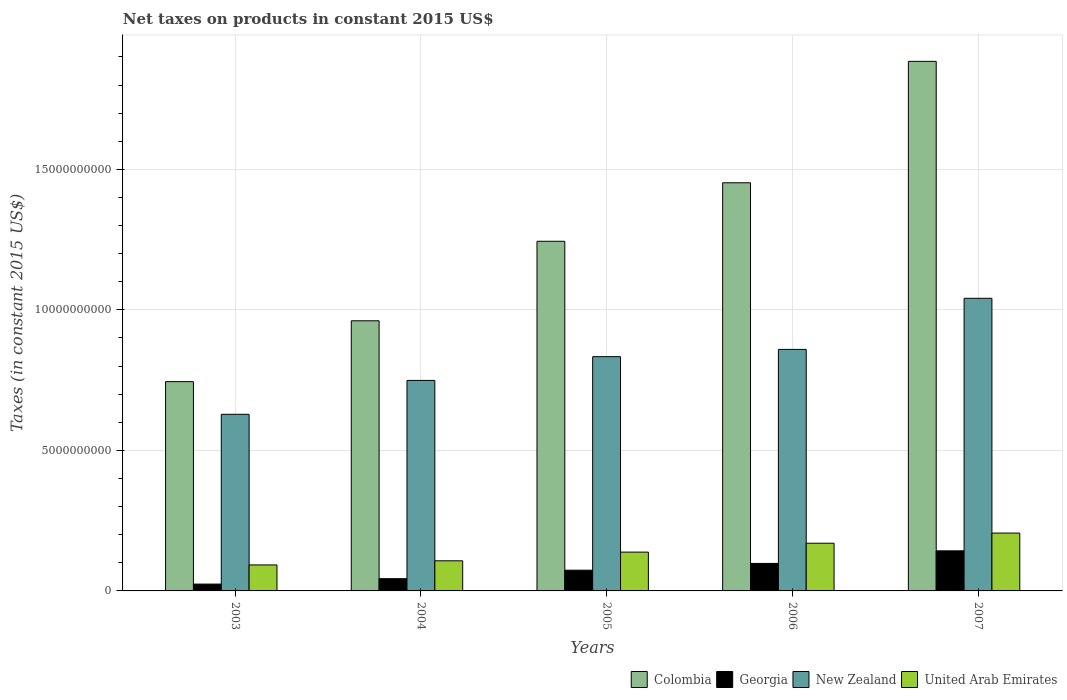How many different coloured bars are there?
Make the answer very short. 4. How many groups of bars are there?
Keep it short and to the point. 5. Are the number of bars on each tick of the X-axis equal?
Ensure brevity in your answer.  Yes. How many bars are there on the 4th tick from the right?
Your response must be concise. 4. What is the net taxes on products in Colombia in 2005?
Make the answer very short. 1.24e+1. Across all years, what is the maximum net taxes on products in New Zealand?
Make the answer very short. 1.04e+1. Across all years, what is the minimum net taxes on products in United Arab Emirates?
Offer a terse response. 9.25e+08. What is the total net taxes on products in New Zealand in the graph?
Keep it short and to the point. 4.11e+1. What is the difference between the net taxes on products in Georgia in 2005 and that in 2007?
Provide a succinct answer. -6.89e+08. What is the difference between the net taxes on products in Georgia in 2005 and the net taxes on products in Colombia in 2006?
Ensure brevity in your answer.  -1.38e+1. What is the average net taxes on products in Colombia per year?
Offer a terse response. 1.26e+1. In the year 2007, what is the difference between the net taxes on products in Colombia and net taxes on products in New Zealand?
Ensure brevity in your answer.  8.43e+09. What is the ratio of the net taxes on products in United Arab Emirates in 2003 to that in 2005?
Provide a succinct answer. 0.67. What is the difference between the highest and the second highest net taxes on products in Georgia?
Provide a short and direct response. 4.47e+08. What is the difference between the highest and the lowest net taxes on products in Colombia?
Make the answer very short. 1.14e+1. Is the sum of the net taxes on products in Georgia in 2004 and 2007 greater than the maximum net taxes on products in Colombia across all years?
Provide a short and direct response. No. Is it the case that in every year, the sum of the net taxes on products in New Zealand and net taxes on products in Georgia is greater than the sum of net taxes on products in Colombia and net taxes on products in United Arab Emirates?
Give a very brief answer. No. What does the 3rd bar from the left in 2006 represents?
Make the answer very short. New Zealand. What does the 1st bar from the right in 2005 represents?
Your answer should be compact. United Arab Emirates. How many years are there in the graph?
Your answer should be compact. 5. Are the values on the major ticks of Y-axis written in scientific E-notation?
Your answer should be very brief. No. Does the graph contain any zero values?
Your answer should be compact. No. How many legend labels are there?
Provide a short and direct response. 4. What is the title of the graph?
Your answer should be very brief. Net taxes on products in constant 2015 US$. Does "Kiribati" appear as one of the legend labels in the graph?
Offer a very short reply. No. What is the label or title of the Y-axis?
Keep it short and to the point. Taxes (in constant 2015 US$). What is the Taxes (in constant 2015 US$) of Colombia in 2003?
Give a very brief answer. 7.45e+09. What is the Taxes (in constant 2015 US$) in Georgia in 2003?
Your response must be concise. 2.43e+08. What is the Taxes (in constant 2015 US$) of New Zealand in 2003?
Make the answer very short. 6.28e+09. What is the Taxes (in constant 2015 US$) of United Arab Emirates in 2003?
Your answer should be compact. 9.25e+08. What is the Taxes (in constant 2015 US$) in Colombia in 2004?
Offer a terse response. 9.61e+09. What is the Taxes (in constant 2015 US$) in Georgia in 2004?
Your answer should be very brief. 4.35e+08. What is the Taxes (in constant 2015 US$) in New Zealand in 2004?
Offer a very short reply. 7.49e+09. What is the Taxes (in constant 2015 US$) in United Arab Emirates in 2004?
Make the answer very short. 1.07e+09. What is the Taxes (in constant 2015 US$) of Colombia in 2005?
Offer a very short reply. 1.24e+1. What is the Taxes (in constant 2015 US$) of Georgia in 2005?
Make the answer very short. 7.37e+08. What is the Taxes (in constant 2015 US$) of New Zealand in 2005?
Give a very brief answer. 8.34e+09. What is the Taxes (in constant 2015 US$) in United Arab Emirates in 2005?
Offer a very short reply. 1.38e+09. What is the Taxes (in constant 2015 US$) in Colombia in 2006?
Give a very brief answer. 1.45e+1. What is the Taxes (in constant 2015 US$) in Georgia in 2006?
Provide a short and direct response. 9.79e+08. What is the Taxes (in constant 2015 US$) in New Zealand in 2006?
Give a very brief answer. 8.59e+09. What is the Taxes (in constant 2015 US$) of United Arab Emirates in 2006?
Provide a short and direct response. 1.70e+09. What is the Taxes (in constant 2015 US$) in Colombia in 2007?
Your answer should be very brief. 1.88e+1. What is the Taxes (in constant 2015 US$) of Georgia in 2007?
Give a very brief answer. 1.43e+09. What is the Taxes (in constant 2015 US$) of New Zealand in 2007?
Make the answer very short. 1.04e+1. What is the Taxes (in constant 2015 US$) in United Arab Emirates in 2007?
Provide a short and direct response. 2.06e+09. Across all years, what is the maximum Taxes (in constant 2015 US$) of Colombia?
Offer a very short reply. 1.88e+1. Across all years, what is the maximum Taxes (in constant 2015 US$) of Georgia?
Keep it short and to the point. 1.43e+09. Across all years, what is the maximum Taxes (in constant 2015 US$) in New Zealand?
Keep it short and to the point. 1.04e+1. Across all years, what is the maximum Taxes (in constant 2015 US$) of United Arab Emirates?
Give a very brief answer. 2.06e+09. Across all years, what is the minimum Taxes (in constant 2015 US$) in Colombia?
Your answer should be very brief. 7.45e+09. Across all years, what is the minimum Taxes (in constant 2015 US$) of Georgia?
Offer a very short reply. 2.43e+08. Across all years, what is the minimum Taxes (in constant 2015 US$) of New Zealand?
Your answer should be compact. 6.28e+09. Across all years, what is the minimum Taxes (in constant 2015 US$) in United Arab Emirates?
Ensure brevity in your answer.  9.25e+08. What is the total Taxes (in constant 2015 US$) of Colombia in the graph?
Provide a short and direct response. 6.29e+1. What is the total Taxes (in constant 2015 US$) of Georgia in the graph?
Your answer should be very brief. 3.82e+09. What is the total Taxes (in constant 2015 US$) of New Zealand in the graph?
Your answer should be very brief. 4.11e+1. What is the total Taxes (in constant 2015 US$) in United Arab Emirates in the graph?
Offer a very short reply. 7.13e+09. What is the difference between the Taxes (in constant 2015 US$) in Colombia in 2003 and that in 2004?
Provide a succinct answer. -2.17e+09. What is the difference between the Taxes (in constant 2015 US$) of Georgia in 2003 and that in 2004?
Offer a terse response. -1.92e+08. What is the difference between the Taxes (in constant 2015 US$) in New Zealand in 2003 and that in 2004?
Provide a succinct answer. -1.21e+09. What is the difference between the Taxes (in constant 2015 US$) of United Arab Emirates in 2003 and that in 2004?
Provide a succinct answer. -1.47e+08. What is the difference between the Taxes (in constant 2015 US$) of Colombia in 2003 and that in 2005?
Make the answer very short. -5.00e+09. What is the difference between the Taxes (in constant 2015 US$) of Georgia in 2003 and that in 2005?
Keep it short and to the point. -4.94e+08. What is the difference between the Taxes (in constant 2015 US$) in New Zealand in 2003 and that in 2005?
Give a very brief answer. -2.05e+09. What is the difference between the Taxes (in constant 2015 US$) in United Arab Emirates in 2003 and that in 2005?
Provide a short and direct response. -4.56e+08. What is the difference between the Taxes (in constant 2015 US$) of Colombia in 2003 and that in 2006?
Provide a short and direct response. -7.08e+09. What is the difference between the Taxes (in constant 2015 US$) of Georgia in 2003 and that in 2006?
Ensure brevity in your answer.  -7.36e+08. What is the difference between the Taxes (in constant 2015 US$) of New Zealand in 2003 and that in 2006?
Provide a succinct answer. -2.31e+09. What is the difference between the Taxes (in constant 2015 US$) of United Arab Emirates in 2003 and that in 2006?
Provide a short and direct response. -7.73e+08. What is the difference between the Taxes (in constant 2015 US$) of Colombia in 2003 and that in 2007?
Offer a terse response. -1.14e+1. What is the difference between the Taxes (in constant 2015 US$) of Georgia in 2003 and that in 2007?
Your answer should be very brief. -1.18e+09. What is the difference between the Taxes (in constant 2015 US$) of New Zealand in 2003 and that in 2007?
Your answer should be compact. -4.13e+09. What is the difference between the Taxes (in constant 2015 US$) of United Arab Emirates in 2003 and that in 2007?
Offer a terse response. -1.13e+09. What is the difference between the Taxes (in constant 2015 US$) of Colombia in 2004 and that in 2005?
Provide a succinct answer. -2.83e+09. What is the difference between the Taxes (in constant 2015 US$) of Georgia in 2004 and that in 2005?
Your answer should be very brief. -3.02e+08. What is the difference between the Taxes (in constant 2015 US$) of New Zealand in 2004 and that in 2005?
Your answer should be compact. -8.45e+08. What is the difference between the Taxes (in constant 2015 US$) of United Arab Emirates in 2004 and that in 2005?
Your response must be concise. -3.09e+08. What is the difference between the Taxes (in constant 2015 US$) of Colombia in 2004 and that in 2006?
Offer a very short reply. -4.91e+09. What is the difference between the Taxes (in constant 2015 US$) in Georgia in 2004 and that in 2006?
Your answer should be compact. -5.44e+08. What is the difference between the Taxes (in constant 2015 US$) of New Zealand in 2004 and that in 2006?
Provide a succinct answer. -1.10e+09. What is the difference between the Taxes (in constant 2015 US$) of United Arab Emirates in 2004 and that in 2006?
Ensure brevity in your answer.  -6.26e+08. What is the difference between the Taxes (in constant 2015 US$) in Colombia in 2004 and that in 2007?
Keep it short and to the point. -9.23e+09. What is the difference between the Taxes (in constant 2015 US$) of Georgia in 2004 and that in 2007?
Provide a succinct answer. -9.91e+08. What is the difference between the Taxes (in constant 2015 US$) in New Zealand in 2004 and that in 2007?
Offer a terse response. -2.92e+09. What is the difference between the Taxes (in constant 2015 US$) of United Arab Emirates in 2004 and that in 2007?
Your answer should be compact. -9.87e+08. What is the difference between the Taxes (in constant 2015 US$) of Colombia in 2005 and that in 2006?
Your response must be concise. -2.08e+09. What is the difference between the Taxes (in constant 2015 US$) in Georgia in 2005 and that in 2006?
Your answer should be very brief. -2.42e+08. What is the difference between the Taxes (in constant 2015 US$) in New Zealand in 2005 and that in 2006?
Make the answer very short. -2.59e+08. What is the difference between the Taxes (in constant 2015 US$) in United Arab Emirates in 2005 and that in 2006?
Ensure brevity in your answer.  -3.17e+08. What is the difference between the Taxes (in constant 2015 US$) in Colombia in 2005 and that in 2007?
Provide a short and direct response. -6.40e+09. What is the difference between the Taxes (in constant 2015 US$) in Georgia in 2005 and that in 2007?
Your response must be concise. -6.89e+08. What is the difference between the Taxes (in constant 2015 US$) of New Zealand in 2005 and that in 2007?
Provide a short and direct response. -2.08e+09. What is the difference between the Taxes (in constant 2015 US$) in United Arab Emirates in 2005 and that in 2007?
Your response must be concise. -6.78e+08. What is the difference between the Taxes (in constant 2015 US$) in Colombia in 2006 and that in 2007?
Make the answer very short. -4.32e+09. What is the difference between the Taxes (in constant 2015 US$) of Georgia in 2006 and that in 2007?
Give a very brief answer. -4.47e+08. What is the difference between the Taxes (in constant 2015 US$) in New Zealand in 2006 and that in 2007?
Your answer should be compact. -1.82e+09. What is the difference between the Taxes (in constant 2015 US$) in United Arab Emirates in 2006 and that in 2007?
Your response must be concise. -3.61e+08. What is the difference between the Taxes (in constant 2015 US$) in Colombia in 2003 and the Taxes (in constant 2015 US$) in Georgia in 2004?
Offer a very short reply. 7.01e+09. What is the difference between the Taxes (in constant 2015 US$) of Colombia in 2003 and the Taxes (in constant 2015 US$) of New Zealand in 2004?
Provide a succinct answer. -4.41e+07. What is the difference between the Taxes (in constant 2015 US$) of Colombia in 2003 and the Taxes (in constant 2015 US$) of United Arab Emirates in 2004?
Offer a terse response. 6.38e+09. What is the difference between the Taxes (in constant 2015 US$) in Georgia in 2003 and the Taxes (in constant 2015 US$) in New Zealand in 2004?
Your answer should be compact. -7.25e+09. What is the difference between the Taxes (in constant 2015 US$) of Georgia in 2003 and the Taxes (in constant 2015 US$) of United Arab Emirates in 2004?
Provide a succinct answer. -8.28e+08. What is the difference between the Taxes (in constant 2015 US$) in New Zealand in 2003 and the Taxes (in constant 2015 US$) in United Arab Emirates in 2004?
Ensure brevity in your answer.  5.21e+09. What is the difference between the Taxes (in constant 2015 US$) in Colombia in 2003 and the Taxes (in constant 2015 US$) in Georgia in 2005?
Your answer should be very brief. 6.71e+09. What is the difference between the Taxes (in constant 2015 US$) in Colombia in 2003 and the Taxes (in constant 2015 US$) in New Zealand in 2005?
Offer a terse response. -8.89e+08. What is the difference between the Taxes (in constant 2015 US$) of Colombia in 2003 and the Taxes (in constant 2015 US$) of United Arab Emirates in 2005?
Offer a very short reply. 6.07e+09. What is the difference between the Taxes (in constant 2015 US$) of Georgia in 2003 and the Taxes (in constant 2015 US$) of New Zealand in 2005?
Ensure brevity in your answer.  -8.09e+09. What is the difference between the Taxes (in constant 2015 US$) of Georgia in 2003 and the Taxes (in constant 2015 US$) of United Arab Emirates in 2005?
Provide a short and direct response. -1.14e+09. What is the difference between the Taxes (in constant 2015 US$) in New Zealand in 2003 and the Taxes (in constant 2015 US$) in United Arab Emirates in 2005?
Provide a succinct answer. 4.90e+09. What is the difference between the Taxes (in constant 2015 US$) in Colombia in 2003 and the Taxes (in constant 2015 US$) in Georgia in 2006?
Provide a short and direct response. 6.47e+09. What is the difference between the Taxes (in constant 2015 US$) of Colombia in 2003 and the Taxes (in constant 2015 US$) of New Zealand in 2006?
Your response must be concise. -1.15e+09. What is the difference between the Taxes (in constant 2015 US$) in Colombia in 2003 and the Taxes (in constant 2015 US$) in United Arab Emirates in 2006?
Provide a short and direct response. 5.75e+09. What is the difference between the Taxes (in constant 2015 US$) in Georgia in 2003 and the Taxes (in constant 2015 US$) in New Zealand in 2006?
Offer a terse response. -8.35e+09. What is the difference between the Taxes (in constant 2015 US$) of Georgia in 2003 and the Taxes (in constant 2015 US$) of United Arab Emirates in 2006?
Offer a very short reply. -1.45e+09. What is the difference between the Taxes (in constant 2015 US$) of New Zealand in 2003 and the Taxes (in constant 2015 US$) of United Arab Emirates in 2006?
Your answer should be very brief. 4.59e+09. What is the difference between the Taxes (in constant 2015 US$) of Colombia in 2003 and the Taxes (in constant 2015 US$) of Georgia in 2007?
Provide a succinct answer. 6.02e+09. What is the difference between the Taxes (in constant 2015 US$) of Colombia in 2003 and the Taxes (in constant 2015 US$) of New Zealand in 2007?
Your answer should be very brief. -2.97e+09. What is the difference between the Taxes (in constant 2015 US$) in Colombia in 2003 and the Taxes (in constant 2015 US$) in United Arab Emirates in 2007?
Your answer should be compact. 5.39e+09. What is the difference between the Taxes (in constant 2015 US$) in Georgia in 2003 and the Taxes (in constant 2015 US$) in New Zealand in 2007?
Make the answer very short. -1.02e+1. What is the difference between the Taxes (in constant 2015 US$) of Georgia in 2003 and the Taxes (in constant 2015 US$) of United Arab Emirates in 2007?
Give a very brief answer. -1.81e+09. What is the difference between the Taxes (in constant 2015 US$) of New Zealand in 2003 and the Taxes (in constant 2015 US$) of United Arab Emirates in 2007?
Your answer should be compact. 4.23e+09. What is the difference between the Taxes (in constant 2015 US$) in Colombia in 2004 and the Taxes (in constant 2015 US$) in Georgia in 2005?
Offer a very short reply. 8.88e+09. What is the difference between the Taxes (in constant 2015 US$) of Colombia in 2004 and the Taxes (in constant 2015 US$) of New Zealand in 2005?
Make the answer very short. 1.28e+09. What is the difference between the Taxes (in constant 2015 US$) of Colombia in 2004 and the Taxes (in constant 2015 US$) of United Arab Emirates in 2005?
Provide a short and direct response. 8.23e+09. What is the difference between the Taxes (in constant 2015 US$) of Georgia in 2004 and the Taxes (in constant 2015 US$) of New Zealand in 2005?
Make the answer very short. -7.90e+09. What is the difference between the Taxes (in constant 2015 US$) of Georgia in 2004 and the Taxes (in constant 2015 US$) of United Arab Emirates in 2005?
Offer a terse response. -9.45e+08. What is the difference between the Taxes (in constant 2015 US$) of New Zealand in 2004 and the Taxes (in constant 2015 US$) of United Arab Emirates in 2005?
Keep it short and to the point. 6.11e+09. What is the difference between the Taxes (in constant 2015 US$) of Colombia in 2004 and the Taxes (in constant 2015 US$) of Georgia in 2006?
Ensure brevity in your answer.  8.63e+09. What is the difference between the Taxes (in constant 2015 US$) of Colombia in 2004 and the Taxes (in constant 2015 US$) of New Zealand in 2006?
Your answer should be compact. 1.02e+09. What is the difference between the Taxes (in constant 2015 US$) in Colombia in 2004 and the Taxes (in constant 2015 US$) in United Arab Emirates in 2006?
Ensure brevity in your answer.  7.92e+09. What is the difference between the Taxes (in constant 2015 US$) of Georgia in 2004 and the Taxes (in constant 2015 US$) of New Zealand in 2006?
Make the answer very short. -8.16e+09. What is the difference between the Taxes (in constant 2015 US$) of Georgia in 2004 and the Taxes (in constant 2015 US$) of United Arab Emirates in 2006?
Provide a short and direct response. -1.26e+09. What is the difference between the Taxes (in constant 2015 US$) of New Zealand in 2004 and the Taxes (in constant 2015 US$) of United Arab Emirates in 2006?
Offer a terse response. 5.79e+09. What is the difference between the Taxes (in constant 2015 US$) in Colombia in 2004 and the Taxes (in constant 2015 US$) in Georgia in 2007?
Offer a very short reply. 8.19e+09. What is the difference between the Taxes (in constant 2015 US$) of Colombia in 2004 and the Taxes (in constant 2015 US$) of New Zealand in 2007?
Give a very brief answer. -8.01e+08. What is the difference between the Taxes (in constant 2015 US$) in Colombia in 2004 and the Taxes (in constant 2015 US$) in United Arab Emirates in 2007?
Provide a succinct answer. 7.55e+09. What is the difference between the Taxes (in constant 2015 US$) of Georgia in 2004 and the Taxes (in constant 2015 US$) of New Zealand in 2007?
Provide a succinct answer. -9.98e+09. What is the difference between the Taxes (in constant 2015 US$) of Georgia in 2004 and the Taxes (in constant 2015 US$) of United Arab Emirates in 2007?
Ensure brevity in your answer.  -1.62e+09. What is the difference between the Taxes (in constant 2015 US$) in New Zealand in 2004 and the Taxes (in constant 2015 US$) in United Arab Emirates in 2007?
Keep it short and to the point. 5.43e+09. What is the difference between the Taxes (in constant 2015 US$) of Colombia in 2005 and the Taxes (in constant 2015 US$) of Georgia in 2006?
Offer a terse response. 1.15e+1. What is the difference between the Taxes (in constant 2015 US$) of Colombia in 2005 and the Taxes (in constant 2015 US$) of New Zealand in 2006?
Offer a terse response. 3.85e+09. What is the difference between the Taxes (in constant 2015 US$) in Colombia in 2005 and the Taxes (in constant 2015 US$) in United Arab Emirates in 2006?
Provide a short and direct response. 1.07e+1. What is the difference between the Taxes (in constant 2015 US$) of Georgia in 2005 and the Taxes (in constant 2015 US$) of New Zealand in 2006?
Give a very brief answer. -7.86e+09. What is the difference between the Taxes (in constant 2015 US$) in Georgia in 2005 and the Taxes (in constant 2015 US$) in United Arab Emirates in 2006?
Keep it short and to the point. -9.60e+08. What is the difference between the Taxes (in constant 2015 US$) of New Zealand in 2005 and the Taxes (in constant 2015 US$) of United Arab Emirates in 2006?
Your answer should be compact. 6.64e+09. What is the difference between the Taxes (in constant 2015 US$) in Colombia in 2005 and the Taxes (in constant 2015 US$) in Georgia in 2007?
Provide a short and direct response. 1.10e+1. What is the difference between the Taxes (in constant 2015 US$) of Colombia in 2005 and the Taxes (in constant 2015 US$) of New Zealand in 2007?
Offer a very short reply. 2.03e+09. What is the difference between the Taxes (in constant 2015 US$) in Colombia in 2005 and the Taxes (in constant 2015 US$) in United Arab Emirates in 2007?
Provide a short and direct response. 1.04e+1. What is the difference between the Taxes (in constant 2015 US$) of Georgia in 2005 and the Taxes (in constant 2015 US$) of New Zealand in 2007?
Provide a short and direct response. -9.68e+09. What is the difference between the Taxes (in constant 2015 US$) of Georgia in 2005 and the Taxes (in constant 2015 US$) of United Arab Emirates in 2007?
Ensure brevity in your answer.  -1.32e+09. What is the difference between the Taxes (in constant 2015 US$) in New Zealand in 2005 and the Taxes (in constant 2015 US$) in United Arab Emirates in 2007?
Provide a succinct answer. 6.28e+09. What is the difference between the Taxes (in constant 2015 US$) in Colombia in 2006 and the Taxes (in constant 2015 US$) in Georgia in 2007?
Your response must be concise. 1.31e+1. What is the difference between the Taxes (in constant 2015 US$) in Colombia in 2006 and the Taxes (in constant 2015 US$) in New Zealand in 2007?
Offer a terse response. 4.11e+09. What is the difference between the Taxes (in constant 2015 US$) in Colombia in 2006 and the Taxes (in constant 2015 US$) in United Arab Emirates in 2007?
Offer a terse response. 1.25e+1. What is the difference between the Taxes (in constant 2015 US$) in Georgia in 2006 and the Taxes (in constant 2015 US$) in New Zealand in 2007?
Offer a terse response. -9.43e+09. What is the difference between the Taxes (in constant 2015 US$) of Georgia in 2006 and the Taxes (in constant 2015 US$) of United Arab Emirates in 2007?
Offer a very short reply. -1.08e+09. What is the difference between the Taxes (in constant 2015 US$) of New Zealand in 2006 and the Taxes (in constant 2015 US$) of United Arab Emirates in 2007?
Provide a short and direct response. 6.54e+09. What is the average Taxes (in constant 2015 US$) of Colombia per year?
Ensure brevity in your answer.  1.26e+1. What is the average Taxes (in constant 2015 US$) of Georgia per year?
Make the answer very short. 7.64e+08. What is the average Taxes (in constant 2015 US$) in New Zealand per year?
Offer a very short reply. 8.22e+09. What is the average Taxes (in constant 2015 US$) of United Arab Emirates per year?
Give a very brief answer. 1.43e+09. In the year 2003, what is the difference between the Taxes (in constant 2015 US$) of Colombia and Taxes (in constant 2015 US$) of Georgia?
Provide a succinct answer. 7.20e+09. In the year 2003, what is the difference between the Taxes (in constant 2015 US$) of Colombia and Taxes (in constant 2015 US$) of New Zealand?
Give a very brief answer. 1.16e+09. In the year 2003, what is the difference between the Taxes (in constant 2015 US$) of Colombia and Taxes (in constant 2015 US$) of United Arab Emirates?
Offer a very short reply. 6.52e+09. In the year 2003, what is the difference between the Taxes (in constant 2015 US$) in Georgia and Taxes (in constant 2015 US$) in New Zealand?
Provide a succinct answer. -6.04e+09. In the year 2003, what is the difference between the Taxes (in constant 2015 US$) of Georgia and Taxes (in constant 2015 US$) of United Arab Emirates?
Your answer should be compact. -6.81e+08. In the year 2003, what is the difference between the Taxes (in constant 2015 US$) in New Zealand and Taxes (in constant 2015 US$) in United Arab Emirates?
Give a very brief answer. 5.36e+09. In the year 2004, what is the difference between the Taxes (in constant 2015 US$) of Colombia and Taxes (in constant 2015 US$) of Georgia?
Provide a succinct answer. 9.18e+09. In the year 2004, what is the difference between the Taxes (in constant 2015 US$) in Colombia and Taxes (in constant 2015 US$) in New Zealand?
Keep it short and to the point. 2.12e+09. In the year 2004, what is the difference between the Taxes (in constant 2015 US$) in Colombia and Taxes (in constant 2015 US$) in United Arab Emirates?
Your answer should be compact. 8.54e+09. In the year 2004, what is the difference between the Taxes (in constant 2015 US$) of Georgia and Taxes (in constant 2015 US$) of New Zealand?
Ensure brevity in your answer.  -7.06e+09. In the year 2004, what is the difference between the Taxes (in constant 2015 US$) of Georgia and Taxes (in constant 2015 US$) of United Arab Emirates?
Offer a terse response. -6.36e+08. In the year 2004, what is the difference between the Taxes (in constant 2015 US$) in New Zealand and Taxes (in constant 2015 US$) in United Arab Emirates?
Give a very brief answer. 6.42e+09. In the year 2005, what is the difference between the Taxes (in constant 2015 US$) of Colombia and Taxes (in constant 2015 US$) of Georgia?
Offer a very short reply. 1.17e+1. In the year 2005, what is the difference between the Taxes (in constant 2015 US$) in Colombia and Taxes (in constant 2015 US$) in New Zealand?
Keep it short and to the point. 4.11e+09. In the year 2005, what is the difference between the Taxes (in constant 2015 US$) of Colombia and Taxes (in constant 2015 US$) of United Arab Emirates?
Give a very brief answer. 1.11e+1. In the year 2005, what is the difference between the Taxes (in constant 2015 US$) in Georgia and Taxes (in constant 2015 US$) in New Zealand?
Give a very brief answer. -7.60e+09. In the year 2005, what is the difference between the Taxes (in constant 2015 US$) of Georgia and Taxes (in constant 2015 US$) of United Arab Emirates?
Keep it short and to the point. -6.43e+08. In the year 2005, what is the difference between the Taxes (in constant 2015 US$) of New Zealand and Taxes (in constant 2015 US$) of United Arab Emirates?
Give a very brief answer. 6.96e+09. In the year 2006, what is the difference between the Taxes (in constant 2015 US$) of Colombia and Taxes (in constant 2015 US$) of Georgia?
Your answer should be compact. 1.35e+1. In the year 2006, what is the difference between the Taxes (in constant 2015 US$) in Colombia and Taxes (in constant 2015 US$) in New Zealand?
Give a very brief answer. 5.93e+09. In the year 2006, what is the difference between the Taxes (in constant 2015 US$) in Colombia and Taxes (in constant 2015 US$) in United Arab Emirates?
Offer a very short reply. 1.28e+1. In the year 2006, what is the difference between the Taxes (in constant 2015 US$) of Georgia and Taxes (in constant 2015 US$) of New Zealand?
Give a very brief answer. -7.62e+09. In the year 2006, what is the difference between the Taxes (in constant 2015 US$) of Georgia and Taxes (in constant 2015 US$) of United Arab Emirates?
Give a very brief answer. -7.18e+08. In the year 2006, what is the difference between the Taxes (in constant 2015 US$) of New Zealand and Taxes (in constant 2015 US$) of United Arab Emirates?
Your response must be concise. 6.90e+09. In the year 2007, what is the difference between the Taxes (in constant 2015 US$) of Colombia and Taxes (in constant 2015 US$) of Georgia?
Give a very brief answer. 1.74e+1. In the year 2007, what is the difference between the Taxes (in constant 2015 US$) of Colombia and Taxes (in constant 2015 US$) of New Zealand?
Offer a very short reply. 8.43e+09. In the year 2007, what is the difference between the Taxes (in constant 2015 US$) in Colombia and Taxes (in constant 2015 US$) in United Arab Emirates?
Give a very brief answer. 1.68e+1. In the year 2007, what is the difference between the Taxes (in constant 2015 US$) in Georgia and Taxes (in constant 2015 US$) in New Zealand?
Your answer should be very brief. -8.99e+09. In the year 2007, what is the difference between the Taxes (in constant 2015 US$) of Georgia and Taxes (in constant 2015 US$) of United Arab Emirates?
Make the answer very short. -6.32e+08. In the year 2007, what is the difference between the Taxes (in constant 2015 US$) of New Zealand and Taxes (in constant 2015 US$) of United Arab Emirates?
Make the answer very short. 8.35e+09. What is the ratio of the Taxes (in constant 2015 US$) in Colombia in 2003 to that in 2004?
Give a very brief answer. 0.77. What is the ratio of the Taxes (in constant 2015 US$) in Georgia in 2003 to that in 2004?
Your answer should be compact. 0.56. What is the ratio of the Taxes (in constant 2015 US$) in New Zealand in 2003 to that in 2004?
Give a very brief answer. 0.84. What is the ratio of the Taxes (in constant 2015 US$) of United Arab Emirates in 2003 to that in 2004?
Your answer should be very brief. 0.86. What is the ratio of the Taxes (in constant 2015 US$) in Colombia in 2003 to that in 2005?
Make the answer very short. 0.6. What is the ratio of the Taxes (in constant 2015 US$) of Georgia in 2003 to that in 2005?
Give a very brief answer. 0.33. What is the ratio of the Taxes (in constant 2015 US$) of New Zealand in 2003 to that in 2005?
Offer a terse response. 0.75. What is the ratio of the Taxes (in constant 2015 US$) of United Arab Emirates in 2003 to that in 2005?
Your response must be concise. 0.67. What is the ratio of the Taxes (in constant 2015 US$) in Colombia in 2003 to that in 2006?
Your answer should be very brief. 0.51. What is the ratio of the Taxes (in constant 2015 US$) of Georgia in 2003 to that in 2006?
Ensure brevity in your answer.  0.25. What is the ratio of the Taxes (in constant 2015 US$) of New Zealand in 2003 to that in 2006?
Provide a succinct answer. 0.73. What is the ratio of the Taxes (in constant 2015 US$) in United Arab Emirates in 2003 to that in 2006?
Ensure brevity in your answer.  0.54. What is the ratio of the Taxes (in constant 2015 US$) of Colombia in 2003 to that in 2007?
Offer a very short reply. 0.4. What is the ratio of the Taxes (in constant 2015 US$) in Georgia in 2003 to that in 2007?
Your answer should be compact. 0.17. What is the ratio of the Taxes (in constant 2015 US$) in New Zealand in 2003 to that in 2007?
Provide a short and direct response. 0.6. What is the ratio of the Taxes (in constant 2015 US$) in United Arab Emirates in 2003 to that in 2007?
Keep it short and to the point. 0.45. What is the ratio of the Taxes (in constant 2015 US$) in Colombia in 2004 to that in 2005?
Provide a short and direct response. 0.77. What is the ratio of the Taxes (in constant 2015 US$) in Georgia in 2004 to that in 2005?
Offer a very short reply. 0.59. What is the ratio of the Taxes (in constant 2015 US$) in New Zealand in 2004 to that in 2005?
Give a very brief answer. 0.9. What is the ratio of the Taxes (in constant 2015 US$) in United Arab Emirates in 2004 to that in 2005?
Your answer should be compact. 0.78. What is the ratio of the Taxes (in constant 2015 US$) in Colombia in 2004 to that in 2006?
Offer a terse response. 0.66. What is the ratio of the Taxes (in constant 2015 US$) of Georgia in 2004 to that in 2006?
Offer a terse response. 0.44. What is the ratio of the Taxes (in constant 2015 US$) of New Zealand in 2004 to that in 2006?
Ensure brevity in your answer.  0.87. What is the ratio of the Taxes (in constant 2015 US$) of United Arab Emirates in 2004 to that in 2006?
Ensure brevity in your answer.  0.63. What is the ratio of the Taxes (in constant 2015 US$) of Colombia in 2004 to that in 2007?
Offer a terse response. 0.51. What is the ratio of the Taxes (in constant 2015 US$) of Georgia in 2004 to that in 2007?
Your answer should be compact. 0.31. What is the ratio of the Taxes (in constant 2015 US$) in New Zealand in 2004 to that in 2007?
Give a very brief answer. 0.72. What is the ratio of the Taxes (in constant 2015 US$) of United Arab Emirates in 2004 to that in 2007?
Provide a short and direct response. 0.52. What is the ratio of the Taxes (in constant 2015 US$) of Colombia in 2005 to that in 2006?
Make the answer very short. 0.86. What is the ratio of the Taxes (in constant 2015 US$) in Georgia in 2005 to that in 2006?
Provide a short and direct response. 0.75. What is the ratio of the Taxes (in constant 2015 US$) of New Zealand in 2005 to that in 2006?
Your answer should be compact. 0.97. What is the ratio of the Taxes (in constant 2015 US$) of United Arab Emirates in 2005 to that in 2006?
Make the answer very short. 0.81. What is the ratio of the Taxes (in constant 2015 US$) of Colombia in 2005 to that in 2007?
Your answer should be compact. 0.66. What is the ratio of the Taxes (in constant 2015 US$) of Georgia in 2005 to that in 2007?
Provide a short and direct response. 0.52. What is the ratio of the Taxes (in constant 2015 US$) of New Zealand in 2005 to that in 2007?
Give a very brief answer. 0.8. What is the ratio of the Taxes (in constant 2015 US$) of United Arab Emirates in 2005 to that in 2007?
Provide a succinct answer. 0.67. What is the ratio of the Taxes (in constant 2015 US$) of Colombia in 2006 to that in 2007?
Your answer should be very brief. 0.77. What is the ratio of the Taxes (in constant 2015 US$) of Georgia in 2006 to that in 2007?
Provide a short and direct response. 0.69. What is the ratio of the Taxes (in constant 2015 US$) of New Zealand in 2006 to that in 2007?
Ensure brevity in your answer.  0.83. What is the ratio of the Taxes (in constant 2015 US$) in United Arab Emirates in 2006 to that in 2007?
Offer a very short reply. 0.82. What is the difference between the highest and the second highest Taxes (in constant 2015 US$) in Colombia?
Your response must be concise. 4.32e+09. What is the difference between the highest and the second highest Taxes (in constant 2015 US$) of Georgia?
Offer a terse response. 4.47e+08. What is the difference between the highest and the second highest Taxes (in constant 2015 US$) of New Zealand?
Keep it short and to the point. 1.82e+09. What is the difference between the highest and the second highest Taxes (in constant 2015 US$) in United Arab Emirates?
Ensure brevity in your answer.  3.61e+08. What is the difference between the highest and the lowest Taxes (in constant 2015 US$) of Colombia?
Provide a succinct answer. 1.14e+1. What is the difference between the highest and the lowest Taxes (in constant 2015 US$) in Georgia?
Your answer should be compact. 1.18e+09. What is the difference between the highest and the lowest Taxes (in constant 2015 US$) in New Zealand?
Your answer should be very brief. 4.13e+09. What is the difference between the highest and the lowest Taxes (in constant 2015 US$) in United Arab Emirates?
Your response must be concise. 1.13e+09. 